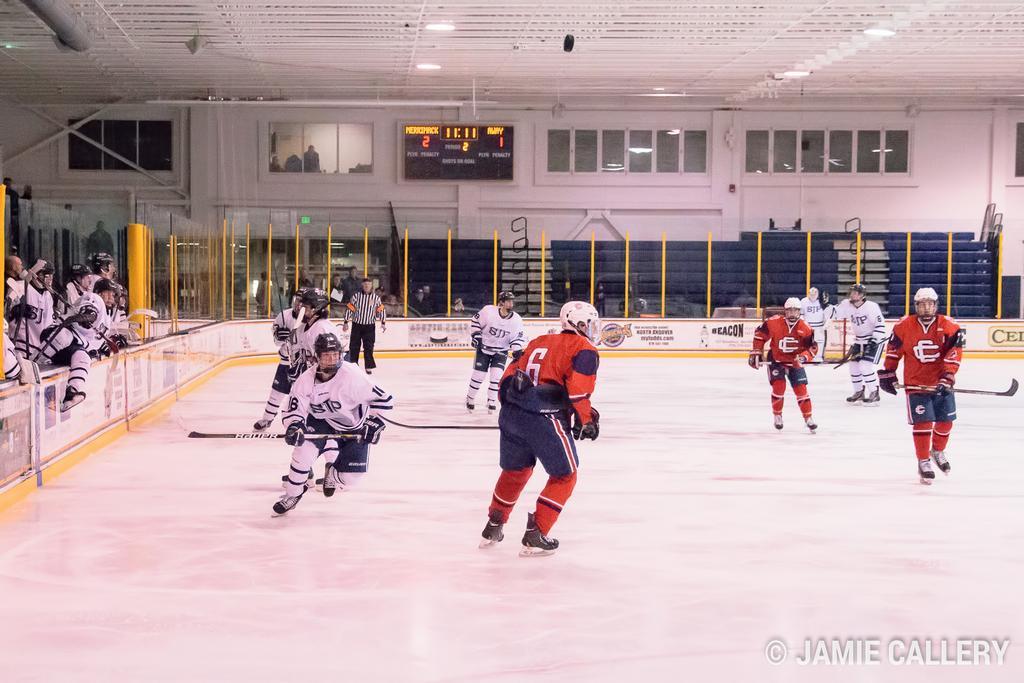Can you describe this image briefly? In this image in the center there are persons playing. On the left side there are persons standing and in the background there are persons sitting and standing and there is a board with some text written on it. There are windows and there is an object which is blue in colour and there are boards with some text written on it and there is a wall which is white in colour. 